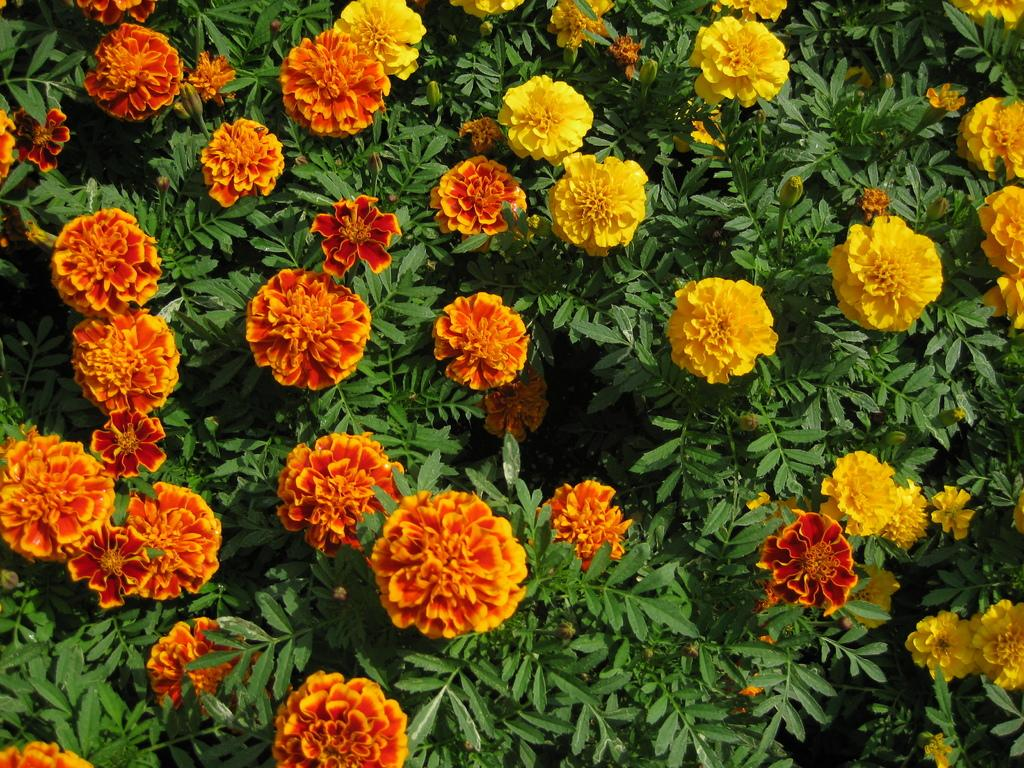What type of living organisms can be seen in the image? Flowers and plants are visible in the image. Can you describe the plants in the image? The plants in the image are not specified, but they are present alongside the flowers. What type of pan is being used to attract the flowers in the image? There is no pan present in the image, and flowers do not require attraction. 